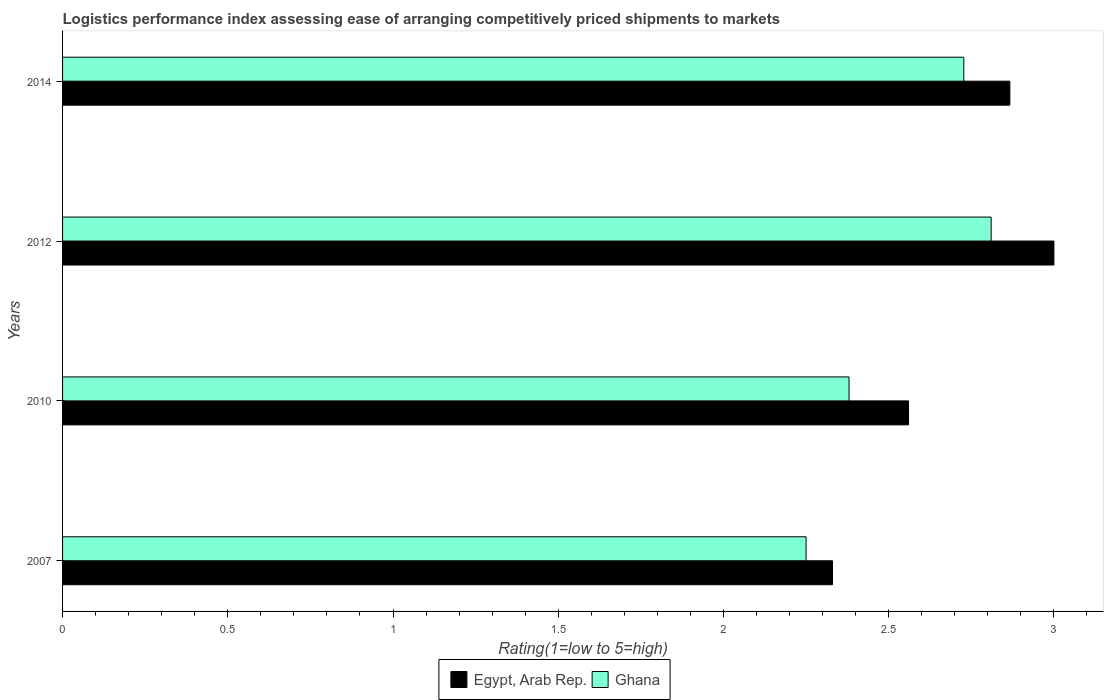How many groups of bars are there?
Provide a succinct answer. 4. Are the number of bars per tick equal to the number of legend labels?
Your response must be concise. Yes. How many bars are there on the 3rd tick from the top?
Provide a short and direct response. 2. In how many cases, is the number of bars for a given year not equal to the number of legend labels?
Keep it short and to the point. 0. What is the Logistic performance index in Ghana in 2012?
Provide a succinct answer. 2.81. Across all years, what is the minimum Logistic performance index in Egypt, Arab Rep.?
Give a very brief answer. 2.33. In which year was the Logistic performance index in Ghana maximum?
Provide a succinct answer. 2012. In which year was the Logistic performance index in Ghana minimum?
Keep it short and to the point. 2007. What is the total Logistic performance index in Ghana in the graph?
Offer a terse response. 10.17. What is the difference between the Logistic performance index in Ghana in 2007 and that in 2014?
Ensure brevity in your answer.  -0.48. What is the difference between the Logistic performance index in Ghana in 2010 and the Logistic performance index in Egypt, Arab Rep. in 2014?
Provide a succinct answer. -0.49. What is the average Logistic performance index in Ghana per year?
Offer a very short reply. 2.54. In the year 2012, what is the difference between the Logistic performance index in Ghana and Logistic performance index in Egypt, Arab Rep.?
Provide a short and direct response. -0.19. In how many years, is the Logistic performance index in Ghana greater than 0.9 ?
Ensure brevity in your answer.  4. What is the ratio of the Logistic performance index in Egypt, Arab Rep. in 2007 to that in 2010?
Offer a very short reply. 0.91. What is the difference between the highest and the second highest Logistic performance index in Ghana?
Give a very brief answer. 0.08. What is the difference between the highest and the lowest Logistic performance index in Ghana?
Provide a short and direct response. 0.56. What does the 2nd bar from the top in 2010 represents?
Provide a short and direct response. Egypt, Arab Rep. What does the 1st bar from the bottom in 2007 represents?
Your answer should be compact. Egypt, Arab Rep. Are all the bars in the graph horizontal?
Make the answer very short. Yes. What is the difference between two consecutive major ticks on the X-axis?
Provide a short and direct response. 0.5. Are the values on the major ticks of X-axis written in scientific E-notation?
Make the answer very short. No. Does the graph contain any zero values?
Provide a short and direct response. No. Does the graph contain grids?
Keep it short and to the point. No. Where does the legend appear in the graph?
Give a very brief answer. Bottom center. How many legend labels are there?
Provide a short and direct response. 2. How are the legend labels stacked?
Provide a short and direct response. Horizontal. What is the title of the graph?
Keep it short and to the point. Logistics performance index assessing ease of arranging competitively priced shipments to markets. What is the label or title of the X-axis?
Your answer should be very brief. Rating(1=low to 5=high). What is the Rating(1=low to 5=high) in Egypt, Arab Rep. in 2007?
Your answer should be compact. 2.33. What is the Rating(1=low to 5=high) in Ghana in 2007?
Your response must be concise. 2.25. What is the Rating(1=low to 5=high) of Egypt, Arab Rep. in 2010?
Make the answer very short. 2.56. What is the Rating(1=low to 5=high) in Ghana in 2010?
Your answer should be very brief. 2.38. What is the Rating(1=low to 5=high) in Egypt, Arab Rep. in 2012?
Ensure brevity in your answer.  3. What is the Rating(1=low to 5=high) of Ghana in 2012?
Your response must be concise. 2.81. What is the Rating(1=low to 5=high) of Egypt, Arab Rep. in 2014?
Provide a short and direct response. 2.87. What is the Rating(1=low to 5=high) in Ghana in 2014?
Provide a short and direct response. 2.73. Across all years, what is the maximum Rating(1=low to 5=high) of Egypt, Arab Rep.?
Offer a terse response. 3. Across all years, what is the maximum Rating(1=low to 5=high) of Ghana?
Offer a very short reply. 2.81. Across all years, what is the minimum Rating(1=low to 5=high) in Egypt, Arab Rep.?
Your answer should be very brief. 2.33. Across all years, what is the minimum Rating(1=low to 5=high) of Ghana?
Give a very brief answer. 2.25. What is the total Rating(1=low to 5=high) in Egypt, Arab Rep. in the graph?
Make the answer very short. 10.76. What is the total Rating(1=low to 5=high) in Ghana in the graph?
Your answer should be compact. 10.17. What is the difference between the Rating(1=low to 5=high) in Egypt, Arab Rep. in 2007 and that in 2010?
Offer a very short reply. -0.23. What is the difference between the Rating(1=low to 5=high) of Ghana in 2007 and that in 2010?
Give a very brief answer. -0.13. What is the difference between the Rating(1=low to 5=high) in Egypt, Arab Rep. in 2007 and that in 2012?
Offer a very short reply. -0.67. What is the difference between the Rating(1=low to 5=high) of Ghana in 2007 and that in 2012?
Your answer should be very brief. -0.56. What is the difference between the Rating(1=low to 5=high) of Egypt, Arab Rep. in 2007 and that in 2014?
Ensure brevity in your answer.  -0.54. What is the difference between the Rating(1=low to 5=high) of Ghana in 2007 and that in 2014?
Your response must be concise. -0.48. What is the difference between the Rating(1=low to 5=high) of Egypt, Arab Rep. in 2010 and that in 2012?
Your response must be concise. -0.44. What is the difference between the Rating(1=low to 5=high) of Ghana in 2010 and that in 2012?
Offer a terse response. -0.43. What is the difference between the Rating(1=low to 5=high) of Egypt, Arab Rep. in 2010 and that in 2014?
Keep it short and to the point. -0.31. What is the difference between the Rating(1=low to 5=high) of Ghana in 2010 and that in 2014?
Your answer should be very brief. -0.35. What is the difference between the Rating(1=low to 5=high) in Egypt, Arab Rep. in 2012 and that in 2014?
Keep it short and to the point. 0.13. What is the difference between the Rating(1=low to 5=high) of Ghana in 2012 and that in 2014?
Offer a very short reply. 0.08. What is the difference between the Rating(1=low to 5=high) of Egypt, Arab Rep. in 2007 and the Rating(1=low to 5=high) of Ghana in 2012?
Offer a terse response. -0.48. What is the difference between the Rating(1=low to 5=high) of Egypt, Arab Rep. in 2007 and the Rating(1=low to 5=high) of Ghana in 2014?
Your answer should be compact. -0.4. What is the difference between the Rating(1=low to 5=high) in Egypt, Arab Rep. in 2010 and the Rating(1=low to 5=high) in Ghana in 2014?
Your answer should be compact. -0.17. What is the difference between the Rating(1=low to 5=high) of Egypt, Arab Rep. in 2012 and the Rating(1=low to 5=high) of Ghana in 2014?
Your answer should be compact. 0.27. What is the average Rating(1=low to 5=high) of Egypt, Arab Rep. per year?
Make the answer very short. 2.69. What is the average Rating(1=low to 5=high) of Ghana per year?
Give a very brief answer. 2.54. In the year 2007, what is the difference between the Rating(1=low to 5=high) of Egypt, Arab Rep. and Rating(1=low to 5=high) of Ghana?
Your response must be concise. 0.08. In the year 2010, what is the difference between the Rating(1=low to 5=high) in Egypt, Arab Rep. and Rating(1=low to 5=high) in Ghana?
Your answer should be very brief. 0.18. In the year 2012, what is the difference between the Rating(1=low to 5=high) of Egypt, Arab Rep. and Rating(1=low to 5=high) of Ghana?
Your answer should be compact. 0.19. In the year 2014, what is the difference between the Rating(1=low to 5=high) of Egypt, Arab Rep. and Rating(1=low to 5=high) of Ghana?
Your answer should be compact. 0.14. What is the ratio of the Rating(1=low to 5=high) in Egypt, Arab Rep. in 2007 to that in 2010?
Your answer should be very brief. 0.91. What is the ratio of the Rating(1=low to 5=high) of Ghana in 2007 to that in 2010?
Make the answer very short. 0.95. What is the ratio of the Rating(1=low to 5=high) in Egypt, Arab Rep. in 2007 to that in 2012?
Offer a terse response. 0.78. What is the ratio of the Rating(1=low to 5=high) in Ghana in 2007 to that in 2012?
Provide a succinct answer. 0.8. What is the ratio of the Rating(1=low to 5=high) of Egypt, Arab Rep. in 2007 to that in 2014?
Offer a terse response. 0.81. What is the ratio of the Rating(1=low to 5=high) of Ghana in 2007 to that in 2014?
Your answer should be very brief. 0.82. What is the ratio of the Rating(1=low to 5=high) in Egypt, Arab Rep. in 2010 to that in 2012?
Ensure brevity in your answer.  0.85. What is the ratio of the Rating(1=low to 5=high) in Ghana in 2010 to that in 2012?
Offer a terse response. 0.85. What is the ratio of the Rating(1=low to 5=high) of Egypt, Arab Rep. in 2010 to that in 2014?
Keep it short and to the point. 0.89. What is the ratio of the Rating(1=low to 5=high) of Ghana in 2010 to that in 2014?
Give a very brief answer. 0.87. What is the ratio of the Rating(1=low to 5=high) in Egypt, Arab Rep. in 2012 to that in 2014?
Provide a succinct answer. 1.05. What is the ratio of the Rating(1=low to 5=high) in Ghana in 2012 to that in 2014?
Your response must be concise. 1.03. What is the difference between the highest and the second highest Rating(1=low to 5=high) of Egypt, Arab Rep.?
Ensure brevity in your answer.  0.13. What is the difference between the highest and the second highest Rating(1=low to 5=high) in Ghana?
Offer a terse response. 0.08. What is the difference between the highest and the lowest Rating(1=low to 5=high) in Egypt, Arab Rep.?
Your answer should be very brief. 0.67. What is the difference between the highest and the lowest Rating(1=low to 5=high) in Ghana?
Offer a terse response. 0.56. 